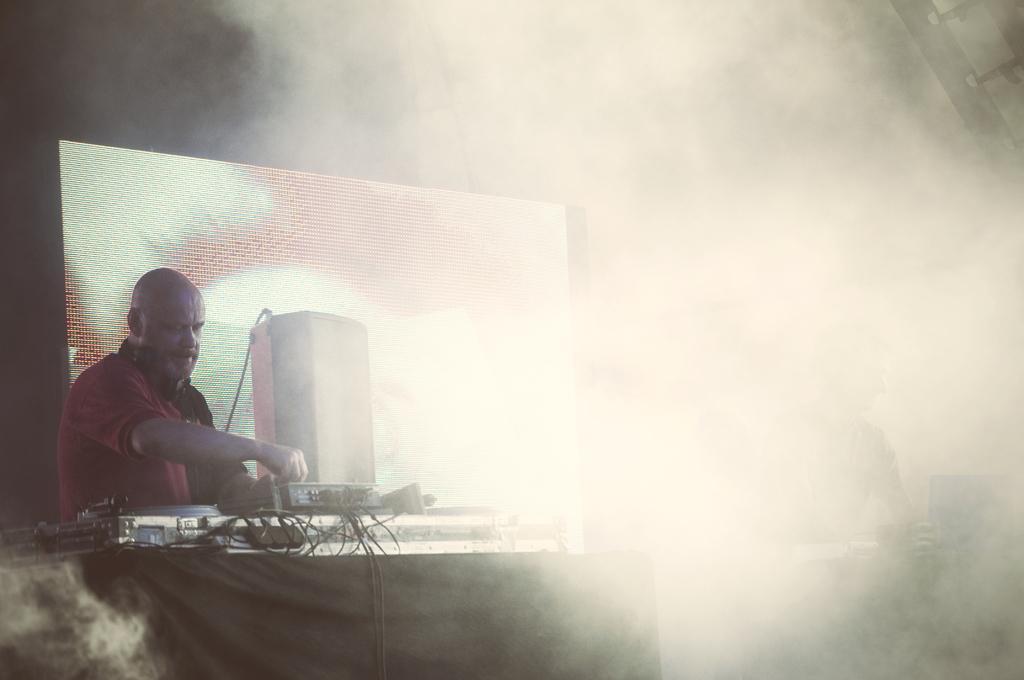In one or two sentences, can you explain what this image depicts? At the bottom of the image there are some tables, on the table there are some musical devices. Behind them two persons are standing. Behind them there is screen and fog. 